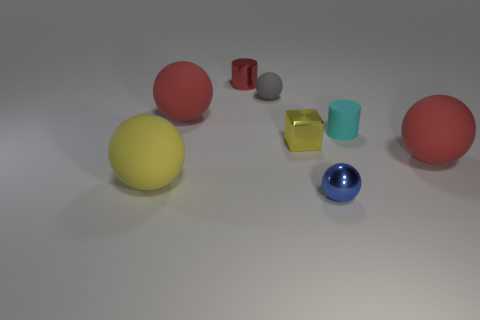What material is the other thing that is the same shape as the cyan rubber thing?
Provide a succinct answer. Metal. Is there any other thing that is the same size as the gray rubber sphere?
Offer a very short reply. Yes. There is a red rubber thing behind the red rubber thing that is on the right side of the red metallic cylinder; what is its size?
Offer a very short reply. Large. What color is the small metal sphere?
Make the answer very short. Blue. What number of shiny objects are to the left of the tiny sphere that is in front of the large yellow ball?
Provide a succinct answer. 2. Are there any cyan cylinders on the right side of the cylinder on the right side of the small yellow metal thing?
Offer a terse response. No. There is a matte cylinder; are there any matte things to the right of it?
Give a very brief answer. Yes. There is a red rubber object on the left side of the small metal cylinder; is it the same shape as the tiny red metallic object?
Provide a succinct answer. No. What number of blue metallic objects have the same shape as the large yellow matte thing?
Ensure brevity in your answer.  1. Is there a cyan block that has the same material as the gray sphere?
Provide a succinct answer. No. 